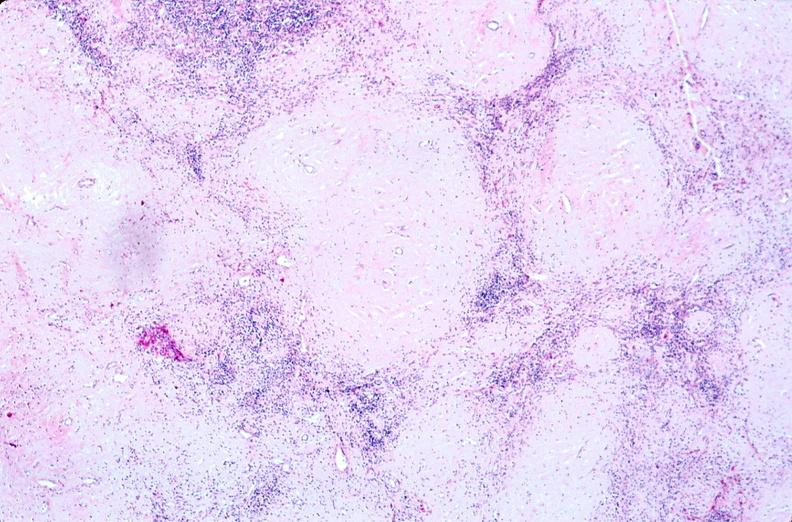does this close-up of cut surface infiltrates show lymph nodes, nodular sclerosing hodgkins disease?
Answer the question using a single word or phrase. No 